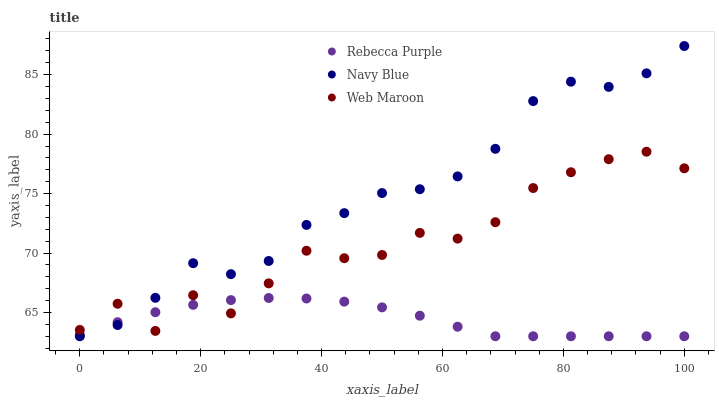Does Rebecca Purple have the minimum area under the curve?
Answer yes or no. Yes. Does Navy Blue have the maximum area under the curve?
Answer yes or no. Yes. Does Web Maroon have the minimum area under the curve?
Answer yes or no. No. Does Web Maroon have the maximum area under the curve?
Answer yes or no. No. Is Rebecca Purple the smoothest?
Answer yes or no. Yes. Is Web Maroon the roughest?
Answer yes or no. Yes. Is Web Maroon the smoothest?
Answer yes or no. No. Is Rebecca Purple the roughest?
Answer yes or no. No. Does Navy Blue have the lowest value?
Answer yes or no. Yes. Does Web Maroon have the lowest value?
Answer yes or no. No. Does Navy Blue have the highest value?
Answer yes or no. Yes. Does Web Maroon have the highest value?
Answer yes or no. No. Does Navy Blue intersect Rebecca Purple?
Answer yes or no. Yes. Is Navy Blue less than Rebecca Purple?
Answer yes or no. No. Is Navy Blue greater than Rebecca Purple?
Answer yes or no. No. 